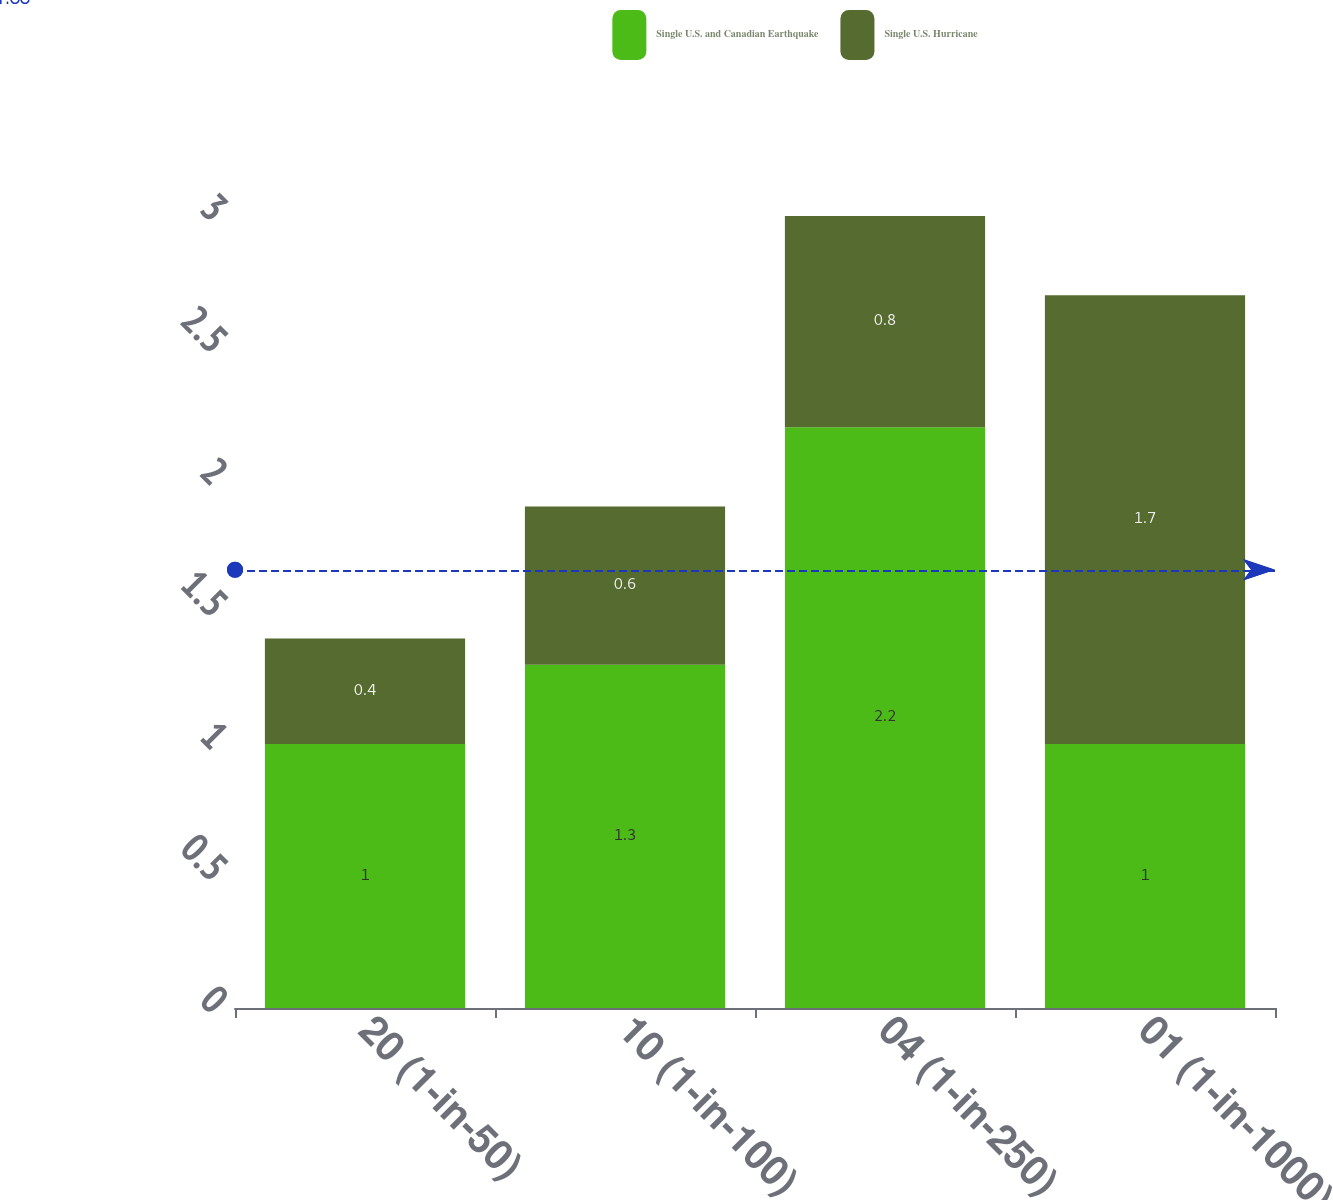Convert chart to OTSL. <chart><loc_0><loc_0><loc_500><loc_500><stacked_bar_chart><ecel><fcel>20 (1-in-50)<fcel>10 (1-in-100)<fcel>04 (1-in-250)<fcel>01 (1-in-1000)<nl><fcel>Single U.S. and Canadian Earthquake<fcel>1<fcel>1.3<fcel>2.2<fcel>1<nl><fcel>Single U.S. Hurricane<fcel>0.4<fcel>0.6<fcel>0.8<fcel>1.7<nl></chart> 